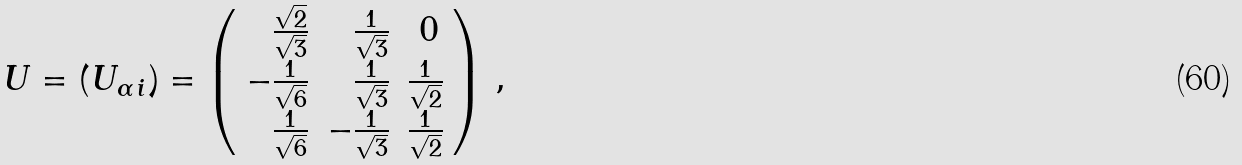<formula> <loc_0><loc_0><loc_500><loc_500>U = ( U _ { \alpha \, i } ) = \left ( \begin{array} { r r r } \frac { \sqrt { 2 } } { \sqrt { 3 } } & \frac { 1 } { \sqrt { 3 } } & 0 \, \\ - \frac { 1 } { \sqrt { 6 } } & \frac { 1 } { \sqrt { 3 } } & \frac { 1 } { \sqrt { 2 } } \\ \frac { 1 } { \sqrt { 6 } } & - \frac { 1 } { \sqrt { 3 } } & \frac { 1 } { \sqrt { 2 } } \end{array} \right ) \, ,</formula> 